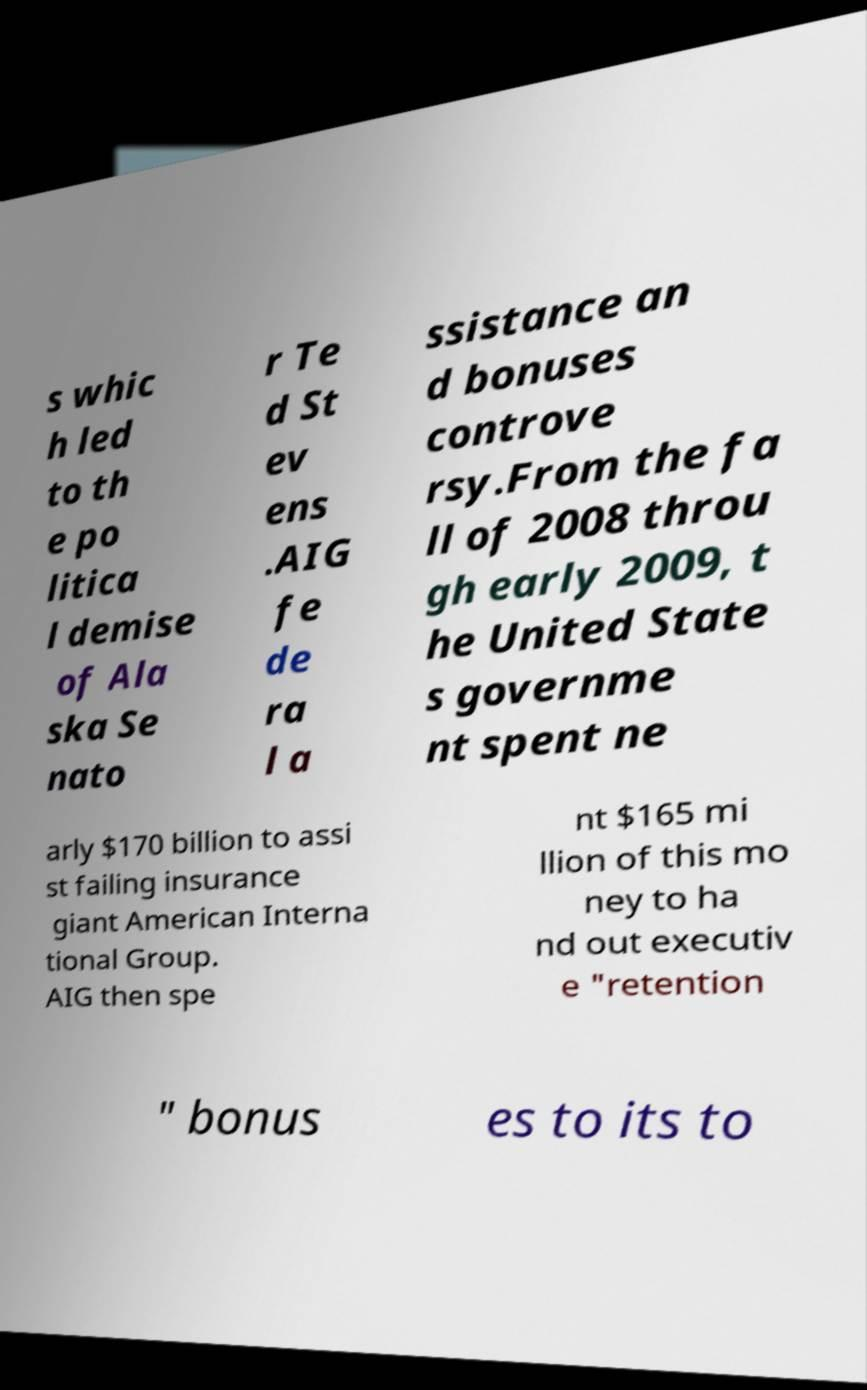Can you read and provide the text displayed in the image?This photo seems to have some interesting text. Can you extract and type it out for me? s whic h led to th e po litica l demise of Ala ska Se nato r Te d St ev ens .AIG fe de ra l a ssistance an d bonuses controve rsy.From the fa ll of 2008 throu gh early 2009, t he United State s governme nt spent ne arly $170 billion to assi st failing insurance giant American Interna tional Group. AIG then spe nt $165 mi llion of this mo ney to ha nd out executiv e "retention " bonus es to its to 